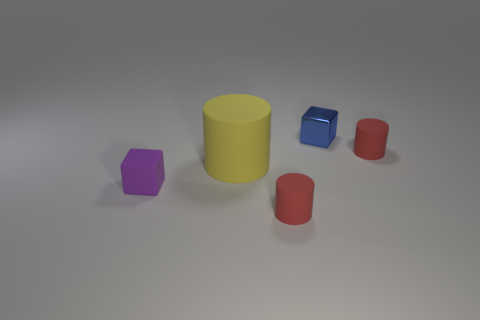Is the shape of the large object the same as the blue metal object?
Keep it short and to the point. No. Is there any other thing that has the same shape as the purple thing?
Give a very brief answer. Yes. Is there a blue metal block?
Your response must be concise. Yes. Is the shape of the small blue metallic object the same as the tiny rubber thing that is in front of the tiny purple rubber block?
Make the answer very short. No. What is the material of the tiny red object that is on the right side of the red rubber cylinder in front of the big yellow rubber thing?
Your response must be concise. Rubber. The big matte object is what color?
Ensure brevity in your answer.  Yellow. Does the matte cylinder that is to the right of the metallic block have the same color as the thing that is on the left side of the large matte cylinder?
Your answer should be very brief. No. There is a shiny object that is the same shape as the purple rubber object; what size is it?
Give a very brief answer. Small. Are there any tiny things that have the same color as the shiny block?
Provide a short and direct response. No. What number of other small blocks are the same color as the rubber block?
Ensure brevity in your answer.  0. 